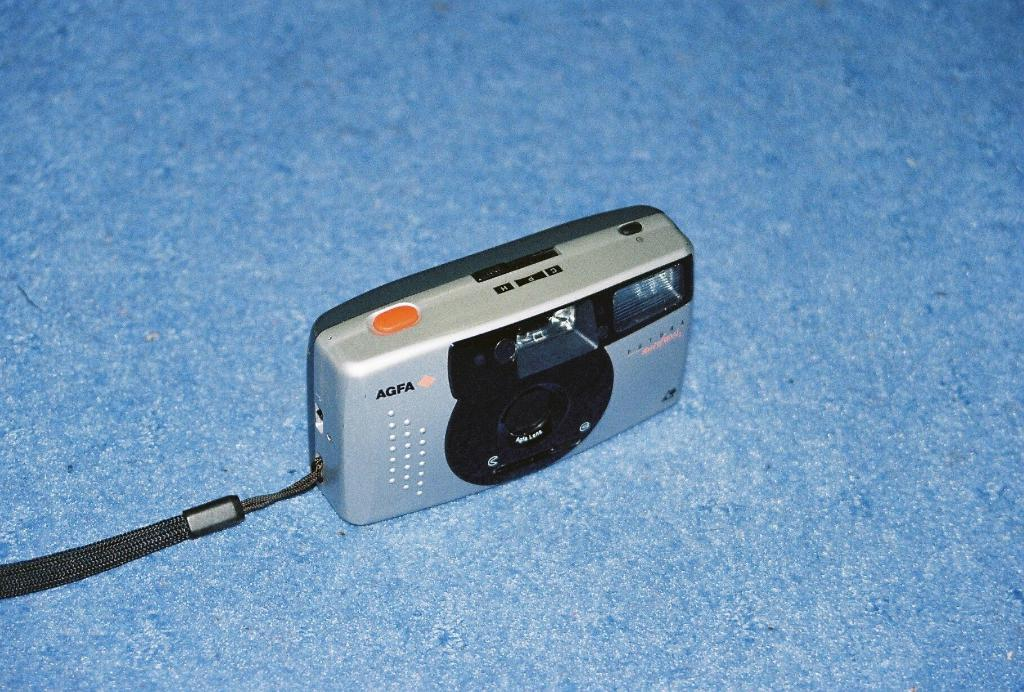What is the main object in the image? There is a camera in the image. What can be seen beneath the camera? The camera is on a blue surface. How does the camera feel about being placed on the blue surface? The camera is an inanimate object and does not have feelings. 